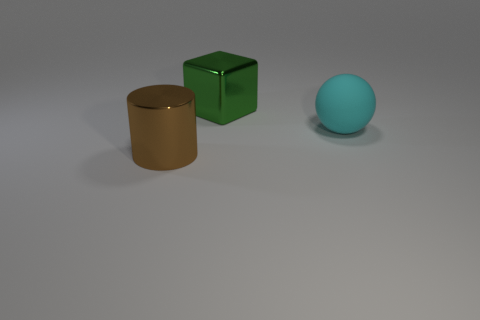Add 3 green cubes. How many objects exist? 6 Subtract all spheres. How many objects are left? 2 Subtract all red cubes. Subtract all purple balls. How many cubes are left? 1 Subtract all yellow blocks. How many yellow spheres are left? 0 Subtract all big green cubes. Subtract all green blocks. How many objects are left? 1 Add 2 big cylinders. How many big cylinders are left? 3 Add 3 big brown shiny cylinders. How many big brown shiny cylinders exist? 4 Subtract 0 red balls. How many objects are left? 3 